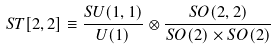<formula> <loc_0><loc_0><loc_500><loc_500>S T [ 2 , 2 ] \equiv \frac { S U ( 1 , 1 ) } { U ( 1 ) } \otimes \frac { S O ( 2 , 2 ) } { S O ( 2 ) \times S O ( 2 ) }</formula> 